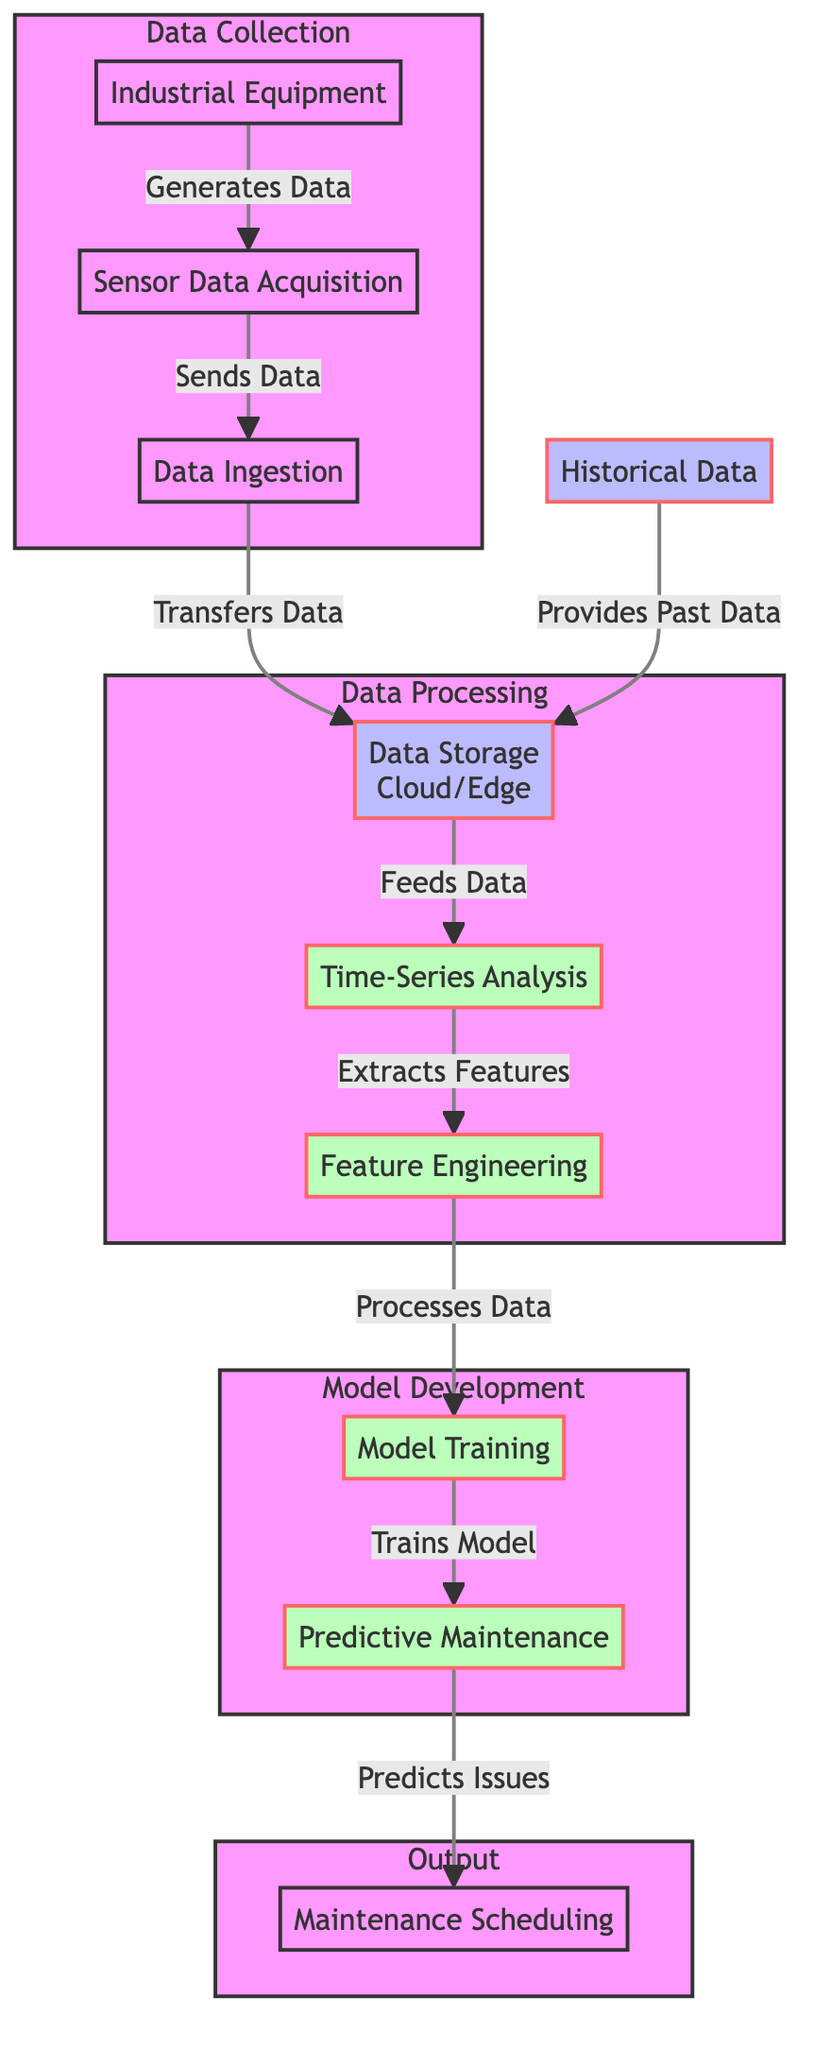What is the first step in the process? The first step in the process is the Industrial Equipment, which generates data and initiates the flow of information.
Answer: Industrial Equipment How many subgraphs are in the diagram? The diagram contains four subgraphs: Data Collection, Data Processing, Model Development, and Output.
Answer: Four What is the role of Historical Data in the diagram? Historical Data provides past data to the Data Storage node, which assists in the overall maintenance predictive process.
Answer: Provides Past Data Which node feeds data into Feature Engineering? The Time-Series Analysis node is responsible for feeding data into the Feature Engineering node after it extracts features from the data.
Answer: Time-Series Analysis What does Model Training produce? Model Training produces a predictive maintenance model that is used to predict potential issues.
Answer: Predictive Maintenance What is the relationship between Feature Engineering and Model Training? Feature Engineering processes the extracted features and sends them to Model Training, which uses these features to train a model for predictive maintenance.
Answer: Processes Data What is the output of the Predictive Maintenance process? The output of the Predictive Maintenance process is Maintenance Scheduling, which organizes when maintenance tasks should occur based on predictions.
Answer: Maintenance Scheduling Which nodes belong to the Data Processing subgraph? The nodes belonging to the Data Processing subgraph are Data Storage, Time-Series Analysis, and Feature Engineering.
Answer: Data Storage, Time-Series Analysis, Feature Engineering Which component directly sends data to Data Storage? The Data Ingestion node directly sends data to the Data Storage node after receiving data from the Sensor Data Acquisition node.
Answer: Data Ingestion What occurs after Model Training is complete? After Model Training is complete, it sends the trained model to the Predictive Maintenance node to predict potential issues with industrial equipment.
Answer: Predictive Maintenance 